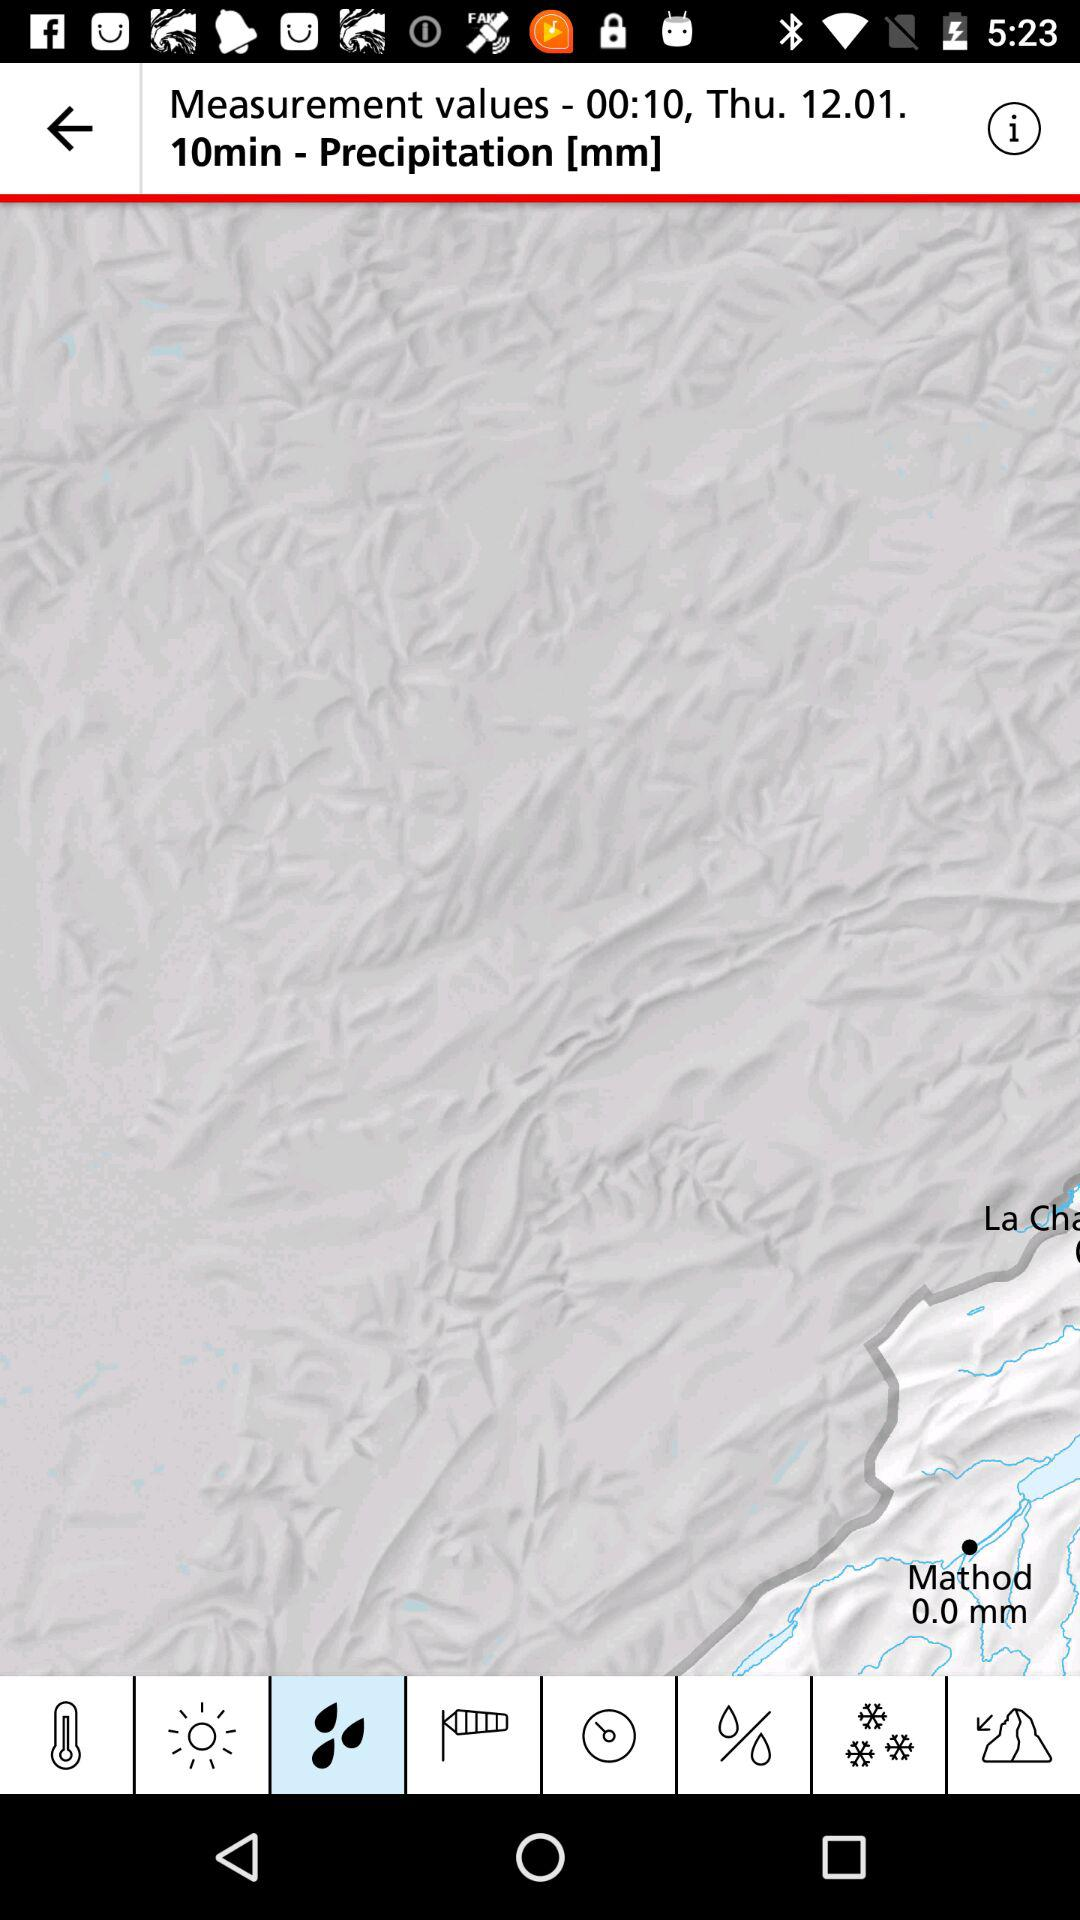What is the unit of calculated precipitation? The unit of calculated precipitation is mm. 